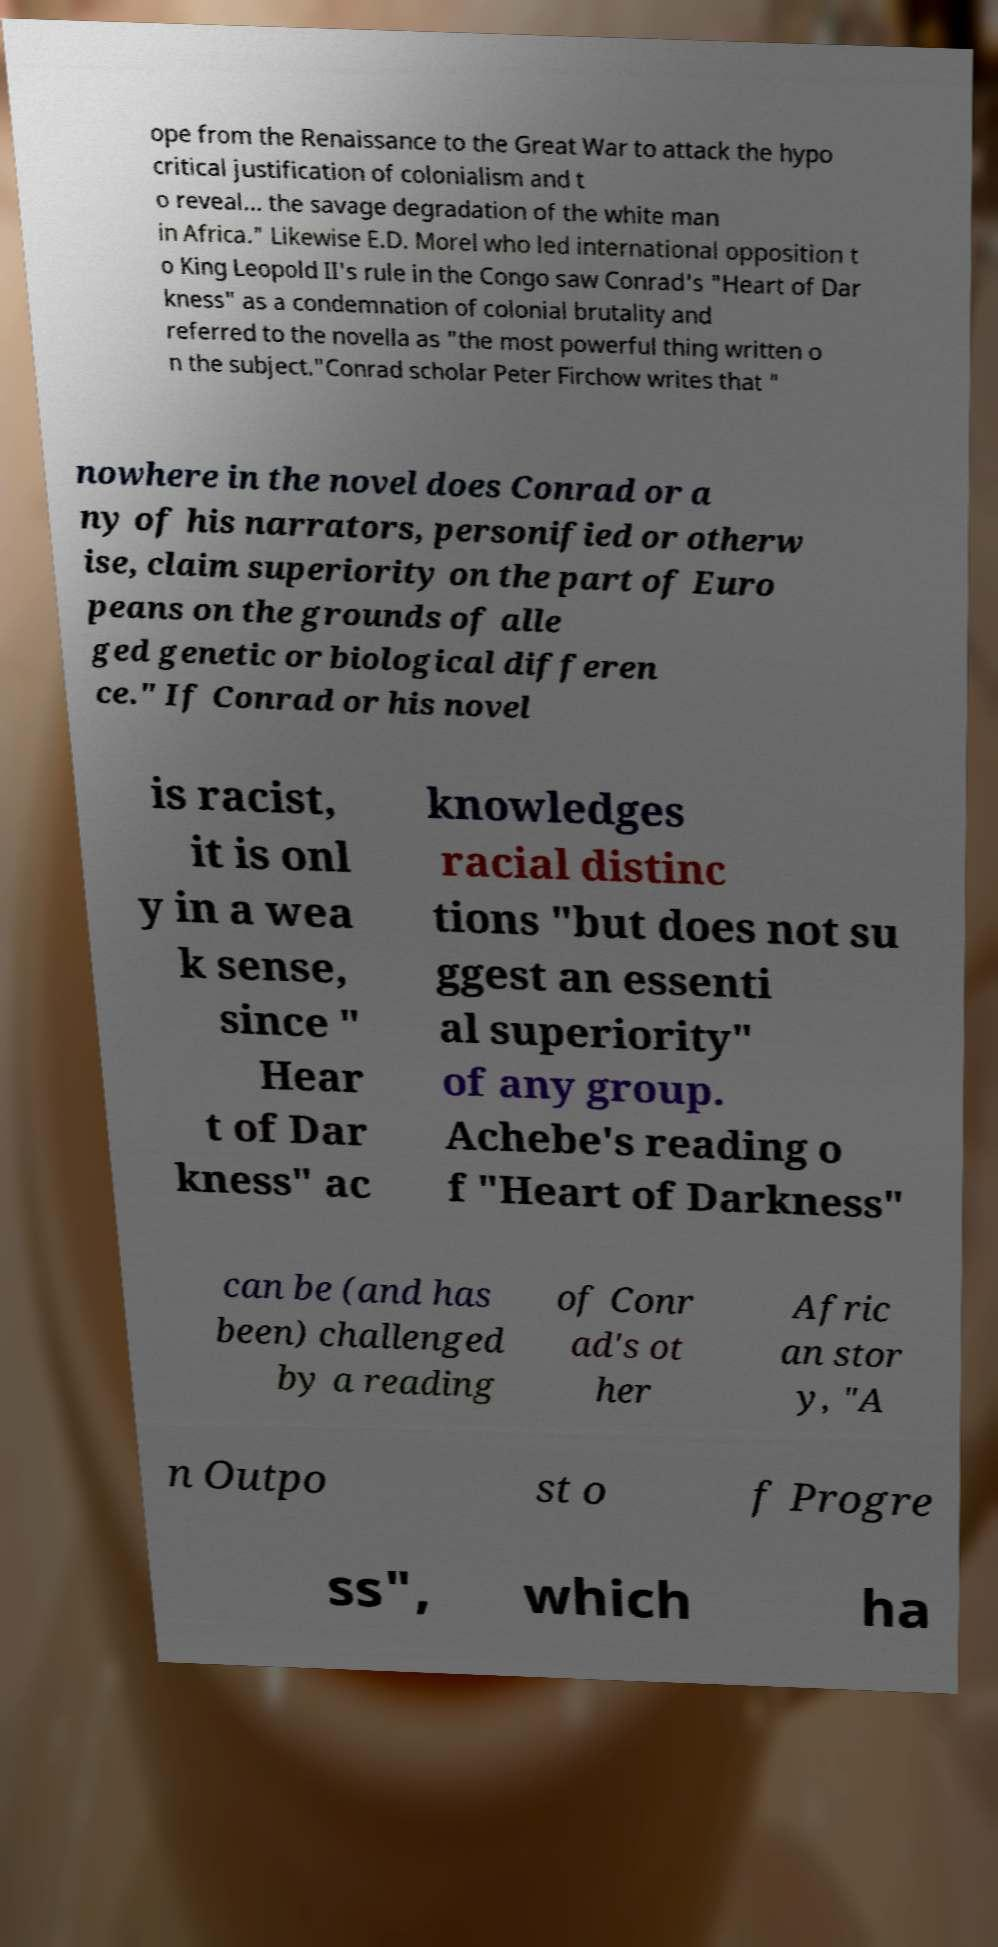Could you extract and type out the text from this image? ope from the Renaissance to the Great War to attack the hypo critical justification of colonialism and t o reveal... the savage degradation of the white man in Africa." Likewise E.D. Morel who led international opposition t o King Leopold II's rule in the Congo saw Conrad's "Heart of Dar kness" as a condemnation of colonial brutality and referred to the novella as "the most powerful thing written o n the subject."Conrad scholar Peter Firchow writes that " nowhere in the novel does Conrad or a ny of his narrators, personified or otherw ise, claim superiority on the part of Euro peans on the grounds of alle ged genetic or biological differen ce." If Conrad or his novel is racist, it is onl y in a wea k sense, since " Hear t of Dar kness" ac knowledges racial distinc tions "but does not su ggest an essenti al superiority" of any group. Achebe's reading o f "Heart of Darkness" can be (and has been) challenged by a reading of Conr ad's ot her Afric an stor y, "A n Outpo st o f Progre ss", which ha 